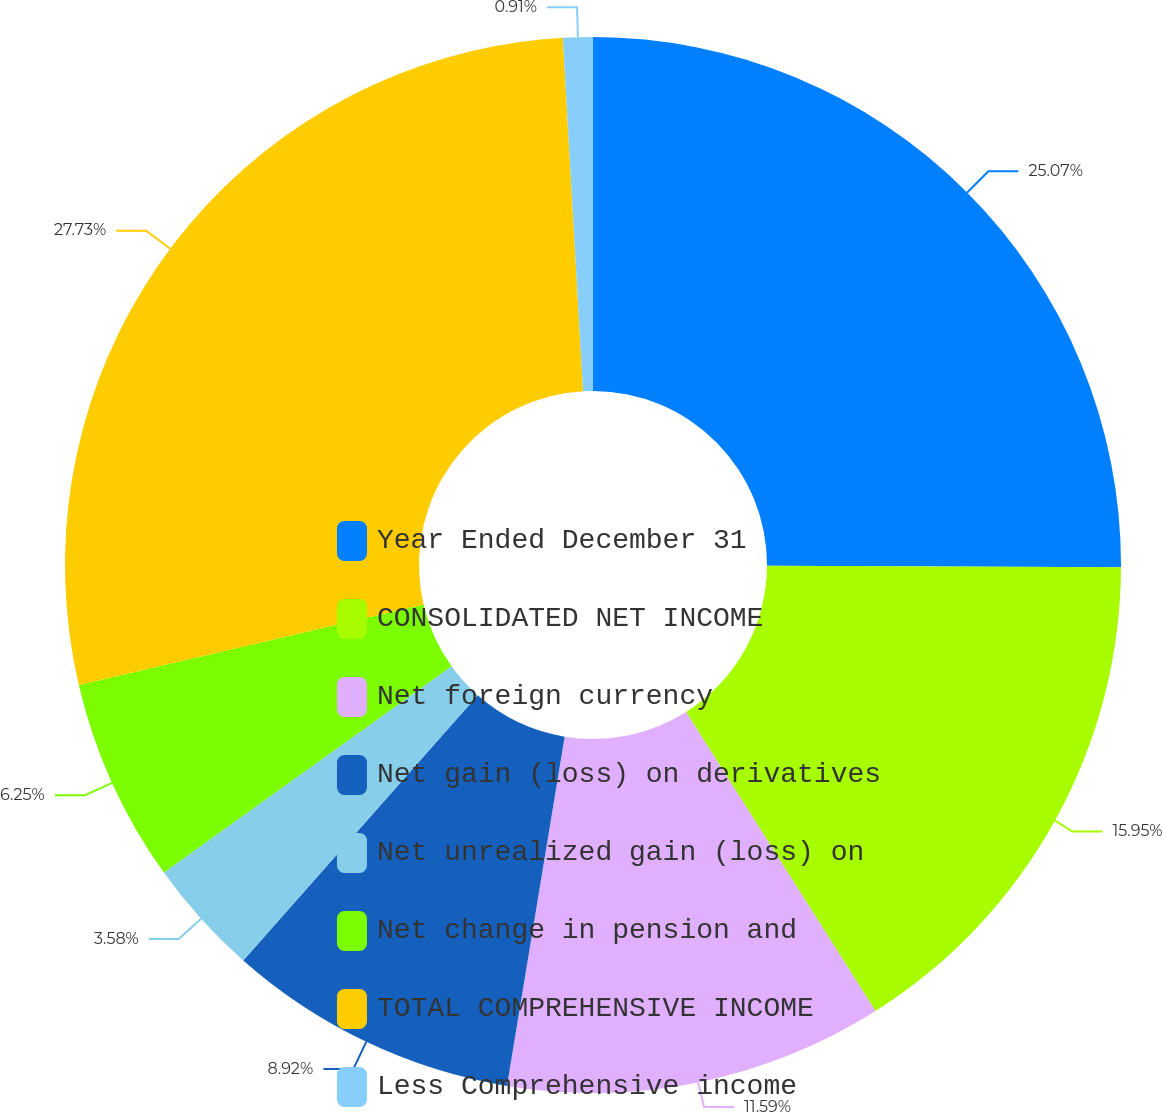<chart> <loc_0><loc_0><loc_500><loc_500><pie_chart><fcel>Year Ended December 31<fcel>CONSOLIDATED NET INCOME<fcel>Net foreign currency<fcel>Net gain (loss) on derivatives<fcel>Net unrealized gain (loss) on<fcel>Net change in pension and<fcel>TOTAL COMPREHENSIVE INCOME<fcel>Less Comprehensive income<nl><fcel>25.07%<fcel>15.95%<fcel>11.59%<fcel>8.92%<fcel>3.58%<fcel>6.25%<fcel>27.74%<fcel>0.91%<nl></chart> 